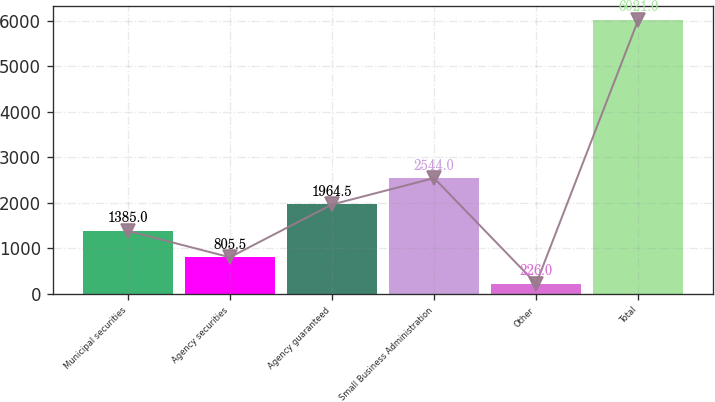<chart> <loc_0><loc_0><loc_500><loc_500><bar_chart><fcel>Municipal securities<fcel>Agency securities<fcel>Agency guaranteed<fcel>Small Business Administration<fcel>Other<fcel>Total<nl><fcel>1385<fcel>805.5<fcel>1964.5<fcel>2544<fcel>226<fcel>6021<nl></chart> 